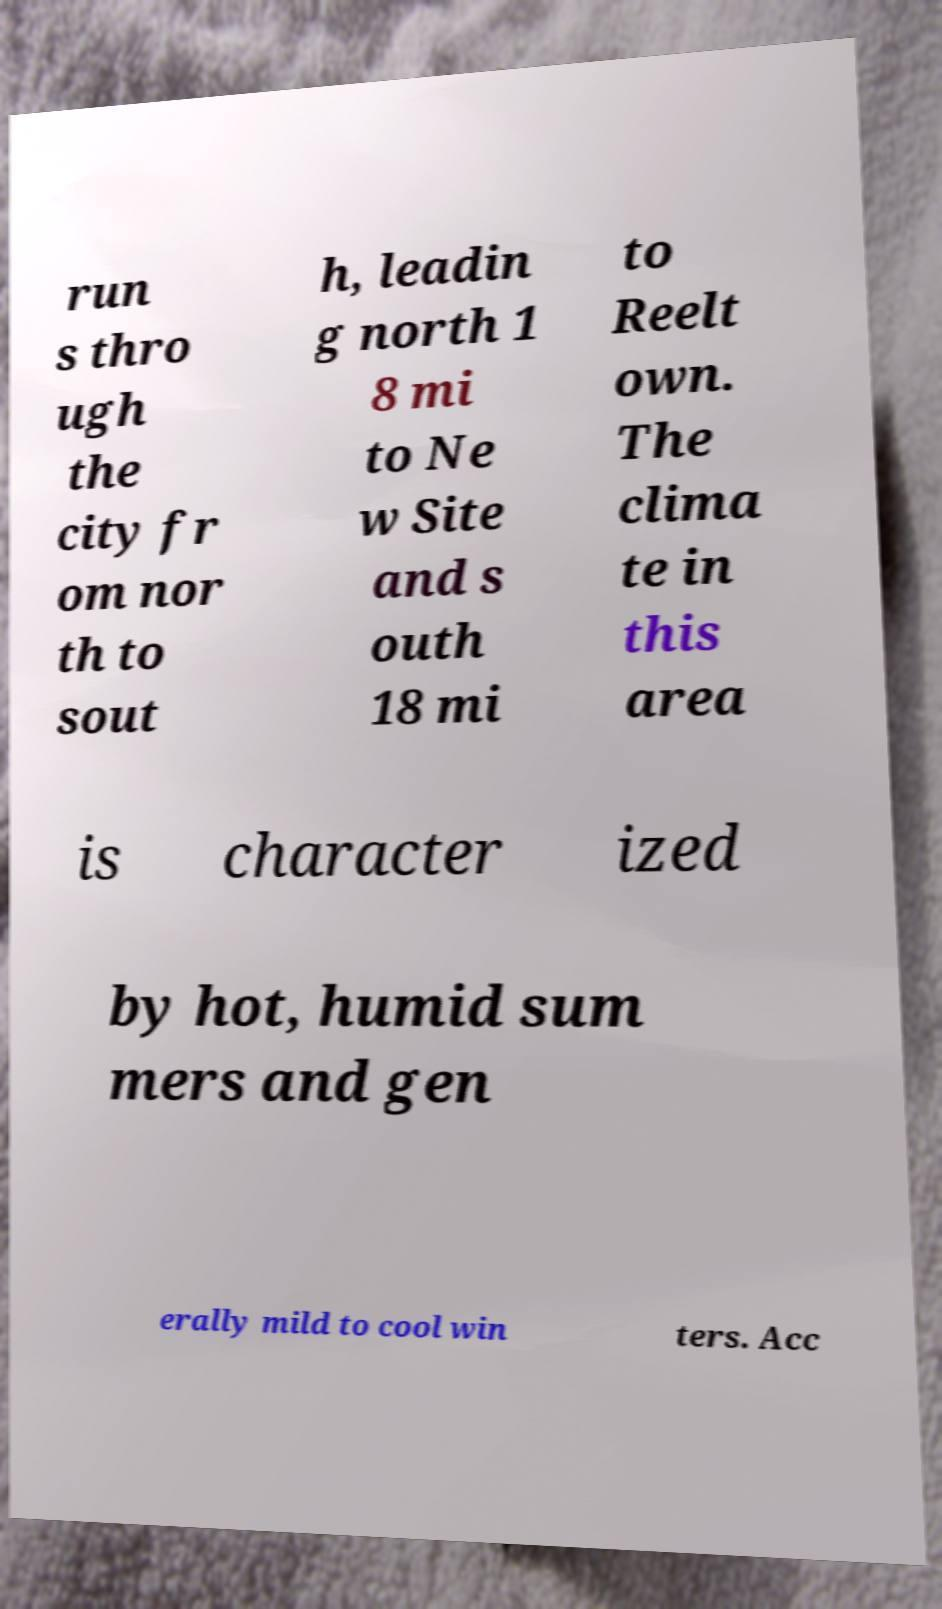There's text embedded in this image that I need extracted. Can you transcribe it verbatim? run s thro ugh the city fr om nor th to sout h, leadin g north 1 8 mi to Ne w Site and s outh 18 mi to Reelt own. The clima te in this area is character ized by hot, humid sum mers and gen erally mild to cool win ters. Acc 